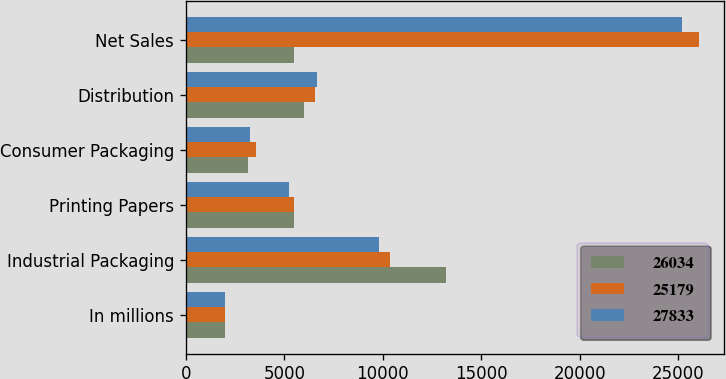Convert chart to OTSL. <chart><loc_0><loc_0><loc_500><loc_500><stacked_bar_chart><ecel><fcel>In millions<fcel>Industrial Packaging<fcel>Printing Papers<fcel>Consumer Packaging<fcel>Distribution<fcel>Net Sales<nl><fcel>26034<fcel>2012<fcel>13223<fcel>5483<fcel>3146<fcel>5981<fcel>5510<nl><fcel>25179<fcel>2011<fcel>10376<fcel>5510<fcel>3577<fcel>6571<fcel>26034<nl><fcel>27833<fcel>2010<fcel>9812<fcel>5220<fcel>3241<fcel>6683<fcel>25179<nl></chart> 